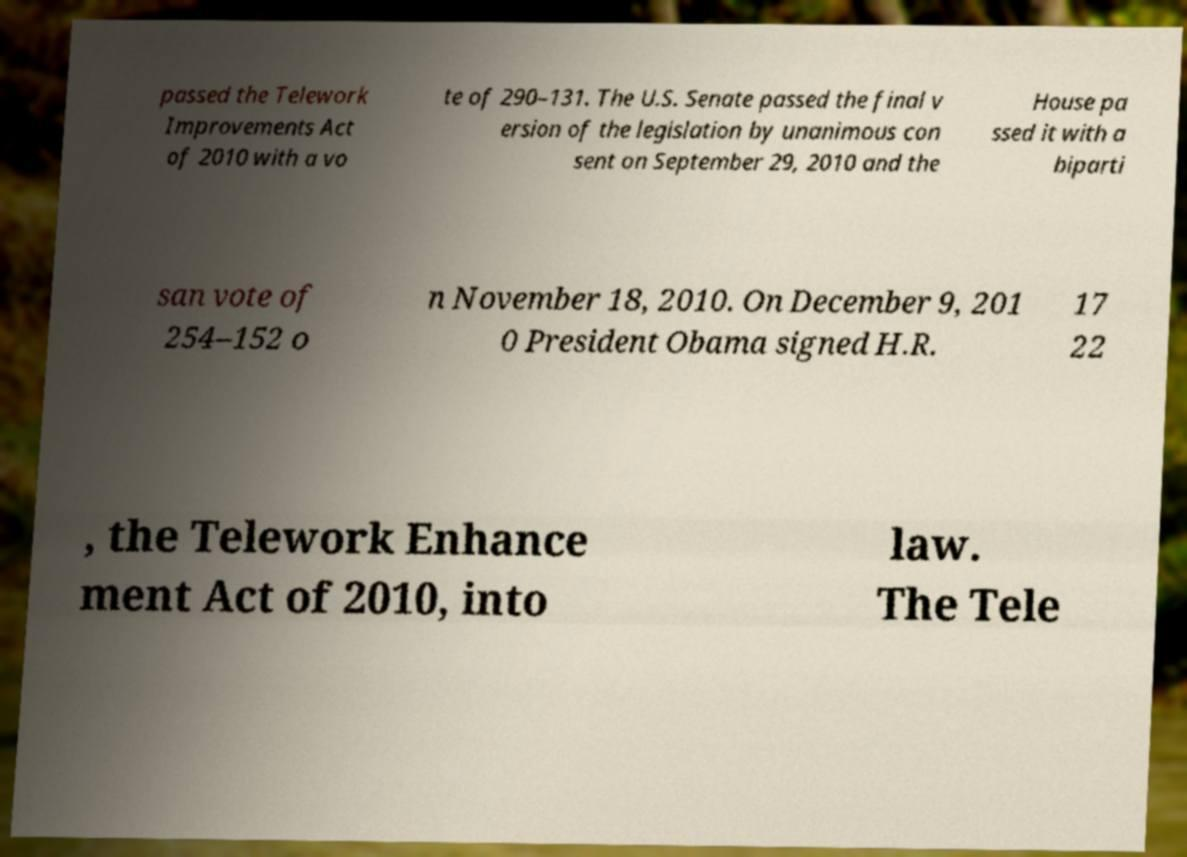What messages or text are displayed in this image? I need them in a readable, typed format. passed the Telework Improvements Act of 2010 with a vo te of 290–131. The U.S. Senate passed the final v ersion of the legislation by unanimous con sent on September 29, 2010 and the House pa ssed it with a biparti san vote of 254–152 o n November 18, 2010. On December 9, 201 0 President Obama signed H.R. 17 22 , the Telework Enhance ment Act of 2010, into law. The Tele 